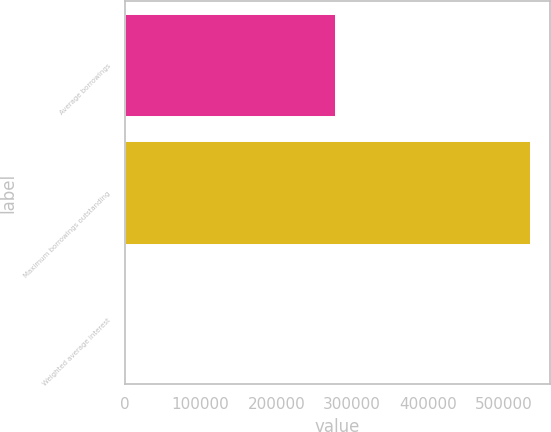Convert chart. <chart><loc_0><loc_0><loc_500><loc_500><bar_chart><fcel>Average borrowings<fcel>Maximum borrowings outstanding<fcel>Weighted average interest<nl><fcel>277952<fcel>534700<fcel>0.46<nl></chart> 